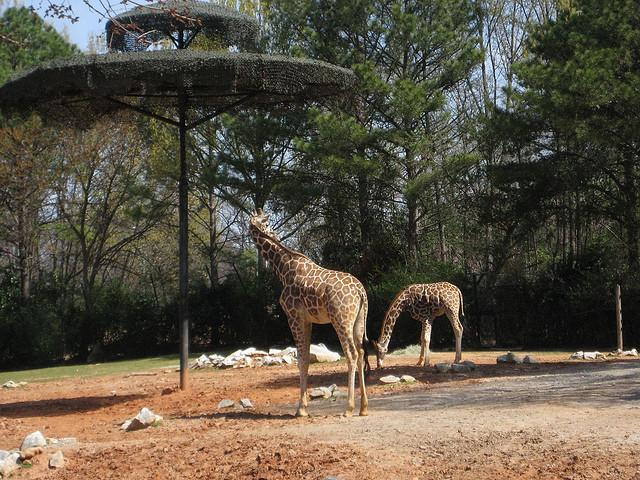What is the umbrella topped structure on the right supposed to resemble? tree 